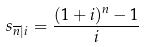<formula> <loc_0><loc_0><loc_500><loc_500>s _ { \overline { n } | i } = \frac { ( 1 + i ) ^ { n } - 1 } { i }</formula> 